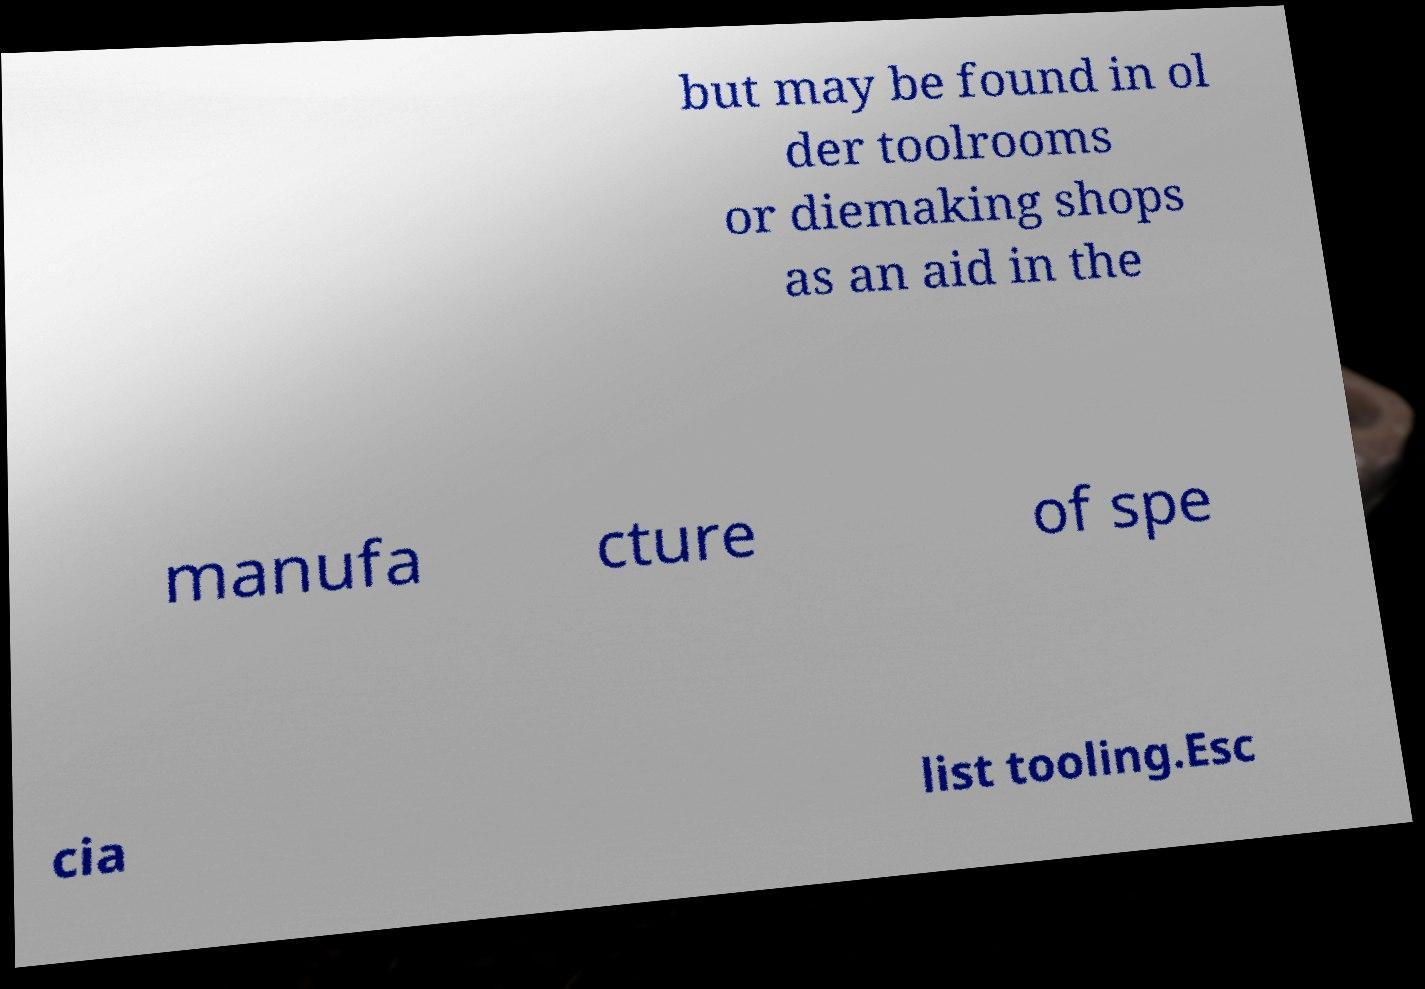What messages or text are displayed in this image? I need them in a readable, typed format. but may be found in ol der toolrooms or diemaking shops as an aid in the manufa cture of spe cia list tooling.Esc 